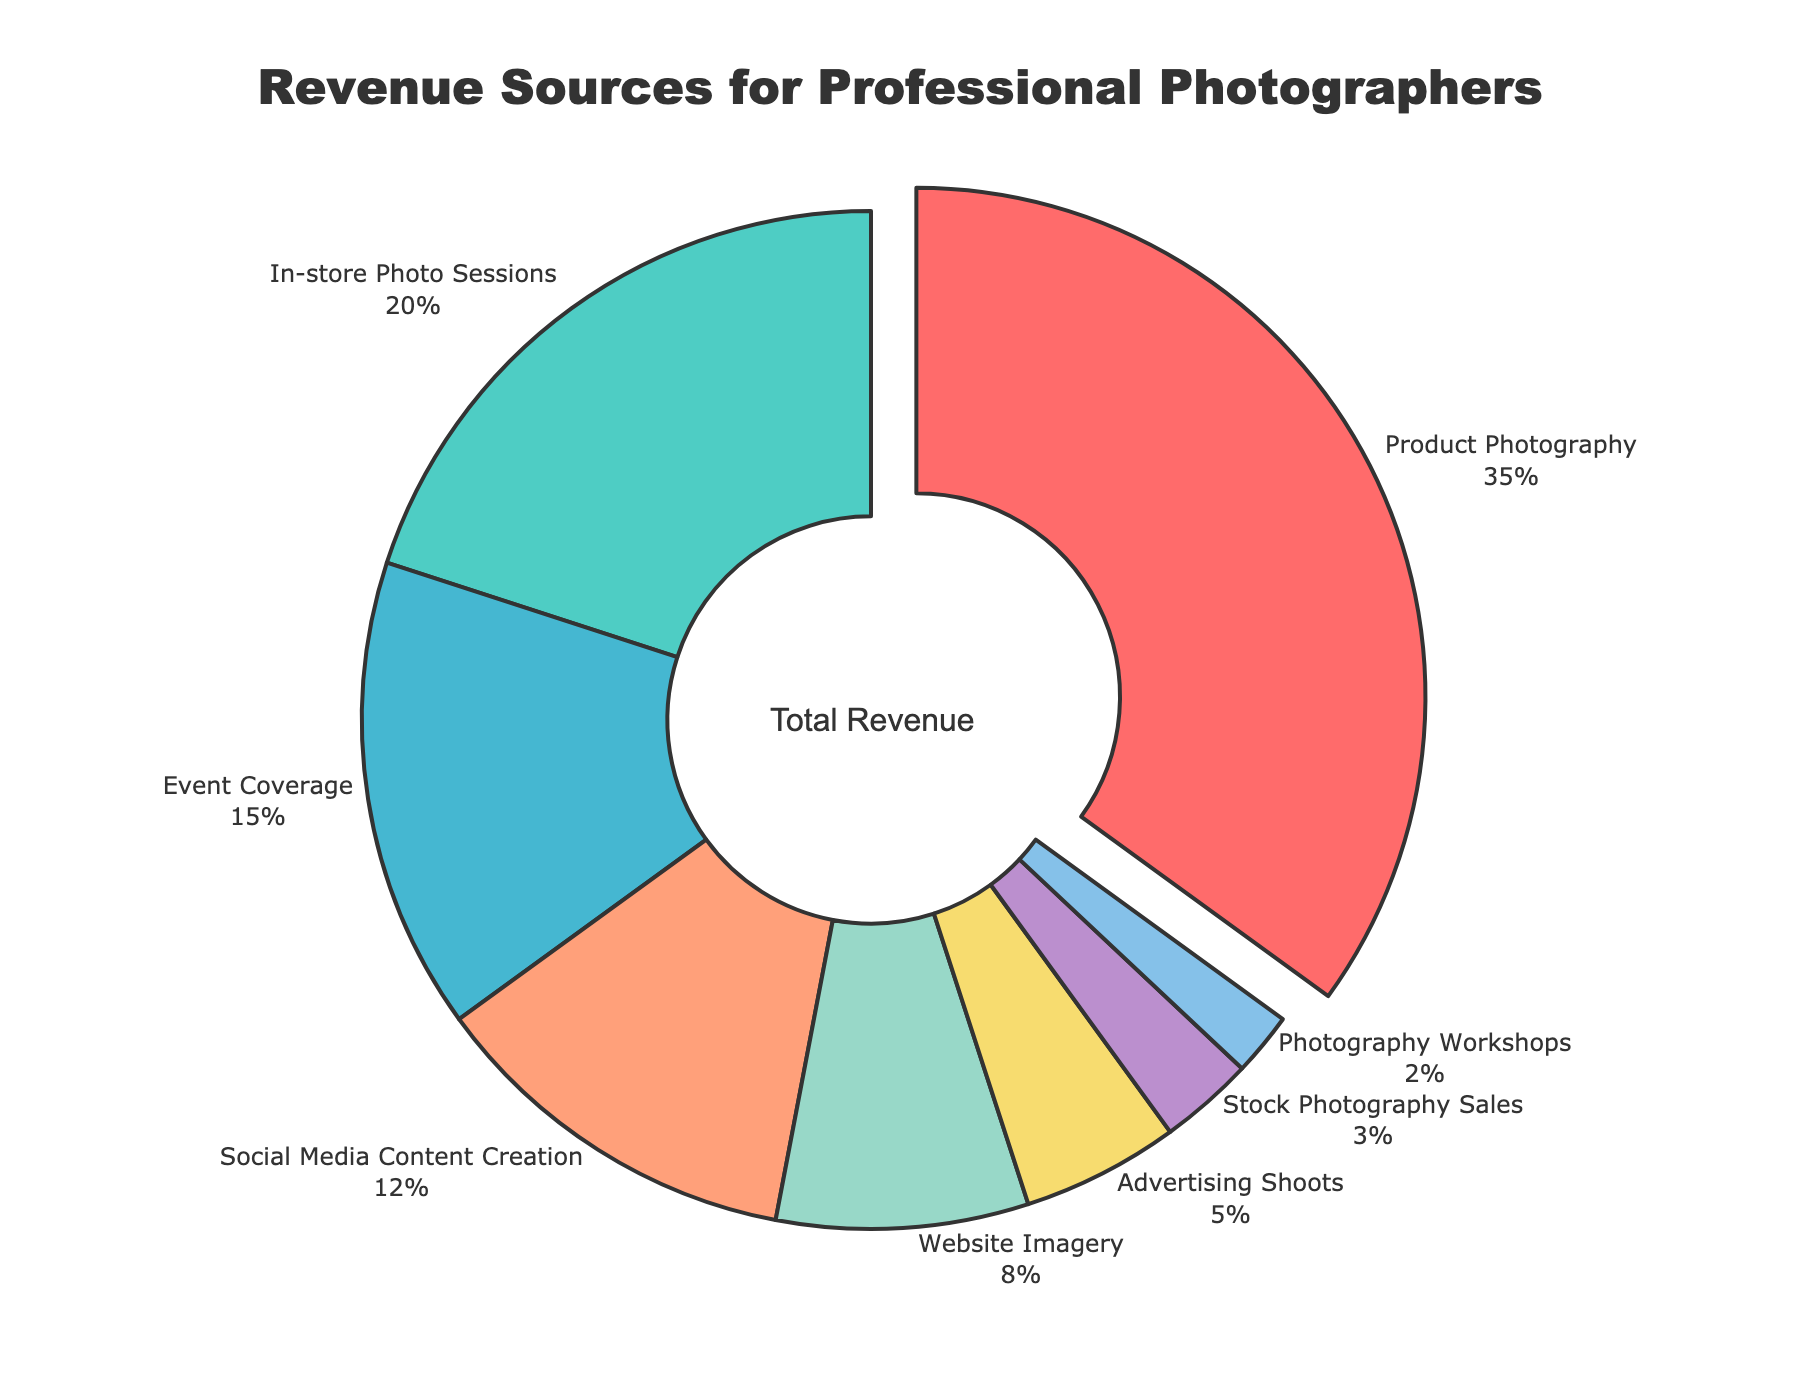What's the largest revenue source for professional photographers in the retail industry? The largest portion of the pie chart is "Product Photography" which is highlighted and pulled out. This indicates it contributes the most to the revenue.
Answer: Product Photography Which revenue source contributes the least to the total revenue? The smallest slice of the pie chart represents "Photography Workshops". This indicates it has the smallest contribution to the total revenue.
Answer: Photography Workshops How does the revenue from In-store Photo Sessions compare to Event Coverage? The pie chart shows that In-store Photo Sessions makes up 20% while Event Coverage contributes 15%. 20% is larger than 15%, so In-store Photo Sessions brings in more revenue than Event Coverage.
Answer: In-store Photo Sessions contributes more What is the combined percentage of revenue from Social Media Content Creation and Advertising Shoots? Social Media Content Creation is 12% and Advertising Shoots is 5%. Adding these together: 12% + 5% = 17%.
Answer: 17% Is the revenue from Website Imagery greater than from Stock Photography Sales? Website Imagery contributes 8% and Stock Photography Sales contributes 3%. 8% is greater than 3%, so the revenue from Website Imagery is greater.
Answer: Yes What percentage of revenue comes from sources other than Product Photography? Product Photography makes up 35%. The rest of the revenue sources therefore make up 100% - 35% = 65%.
Answer: 65% What is the visual marker used to indicate the revenue source with the highest percentage? The pie chart section for the highest percentage (Product Photography) is pulled out slightly from the rest of the chart.
Answer: Pulled out slice If you sum the revenue percentages of the three smallest categories, what do you get? The three smallest categories are Photography Workshops (2%), Stock Photography Sales (3%), and Advertising Shoots (5%). Adding these together: 2% + 3% + 5% = 10%.
Answer: 10% Which category appears third from the top in the pie chart when listed clockwise from the top? The topmost category is Product Photography, followed by In-store Photo Sessions, and the third one is Event Coverage as we move clockwise.
Answer: Event Coverage 